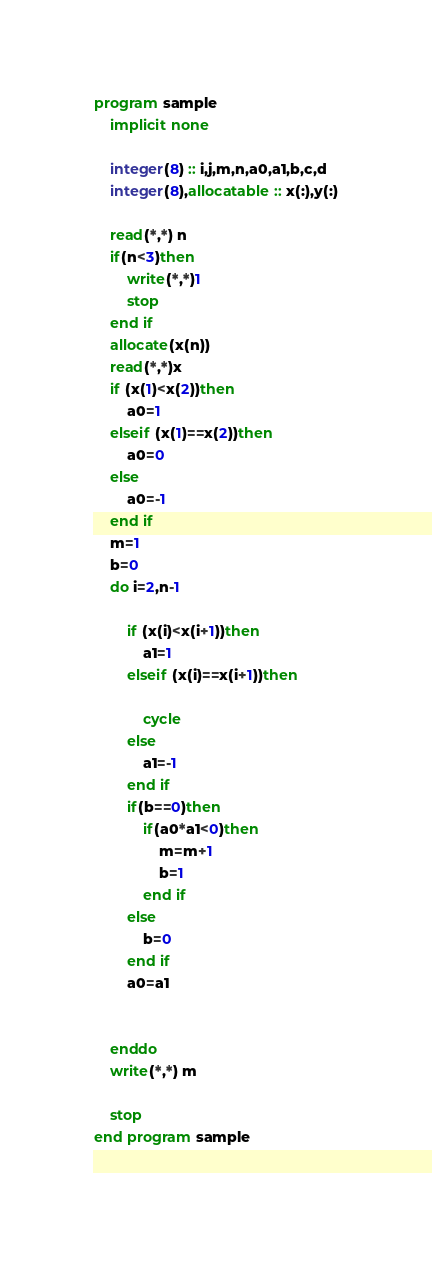<code> <loc_0><loc_0><loc_500><loc_500><_FORTRAN_>program sample
    implicit none
  
    integer(8) :: i,j,m,n,a0,a1,b,c,d
    integer(8),allocatable :: x(:),y(:)
  
    read(*,*) n
    if(n<3)then
        write(*,*)1
        stop
    end if
    allocate(x(n))
    read(*,*)x
    if (x(1)<x(2))then
        a0=1
    elseif (x(1)==x(2))then
        a0=0
    else
        a0=-1
    end if
    m=1
    b=0
    do i=2,n-1
        
        if (x(i)<x(i+1))then
            a1=1
        elseif (x(i)==x(i+1))then
           
            cycle
        else
            a1=-1
        end if
        if(b==0)then
            if(a0*a1<0)then
                m=m+1
                b=1
            end if
        else
            b=0
        end if
        a0=a1
        
        
    enddo
    write(*,*) m
  
    stop
end program sample
  

</code> 